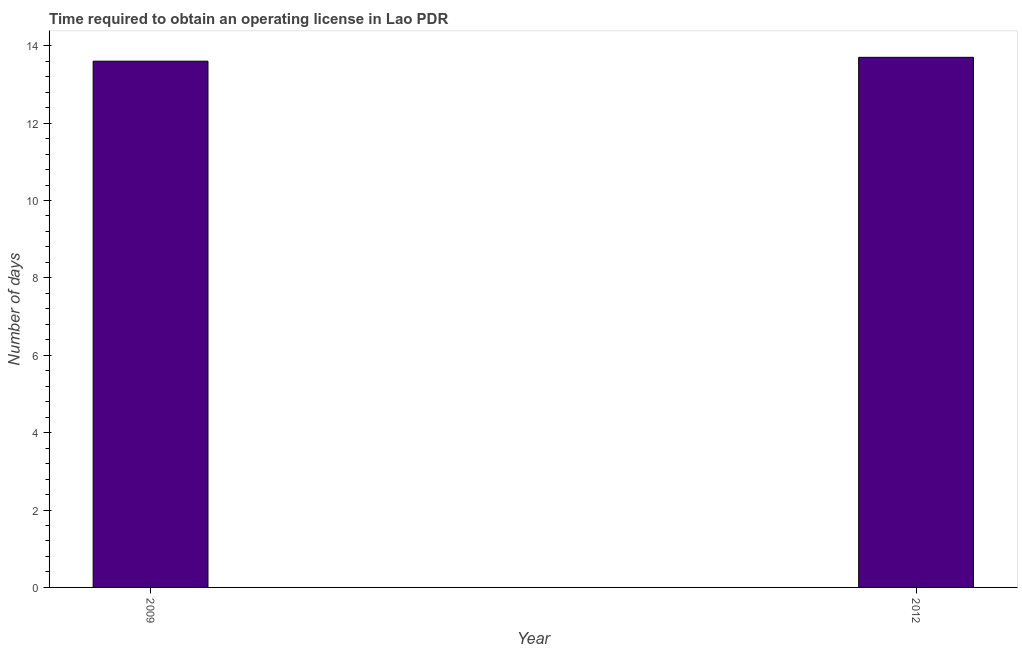Does the graph contain grids?
Your response must be concise. No. What is the title of the graph?
Your answer should be compact. Time required to obtain an operating license in Lao PDR. What is the label or title of the Y-axis?
Your response must be concise. Number of days. Across all years, what is the maximum number of days to obtain operating license?
Offer a very short reply. 13.7. Across all years, what is the minimum number of days to obtain operating license?
Give a very brief answer. 13.6. In which year was the number of days to obtain operating license minimum?
Keep it short and to the point. 2009. What is the sum of the number of days to obtain operating license?
Provide a short and direct response. 27.3. What is the difference between the number of days to obtain operating license in 2009 and 2012?
Your answer should be compact. -0.1. What is the average number of days to obtain operating license per year?
Give a very brief answer. 13.65. What is the median number of days to obtain operating license?
Give a very brief answer. 13.65. In how many years, is the number of days to obtain operating license greater than 8 days?
Make the answer very short. 2. Do a majority of the years between 2009 and 2012 (inclusive) have number of days to obtain operating license greater than 4.4 days?
Provide a short and direct response. Yes. Is the number of days to obtain operating license in 2009 less than that in 2012?
Make the answer very short. Yes. Are all the bars in the graph horizontal?
Your response must be concise. No. How many years are there in the graph?
Your answer should be compact. 2. What is the Number of days in 2012?
Make the answer very short. 13.7. What is the difference between the Number of days in 2009 and 2012?
Ensure brevity in your answer.  -0.1. 